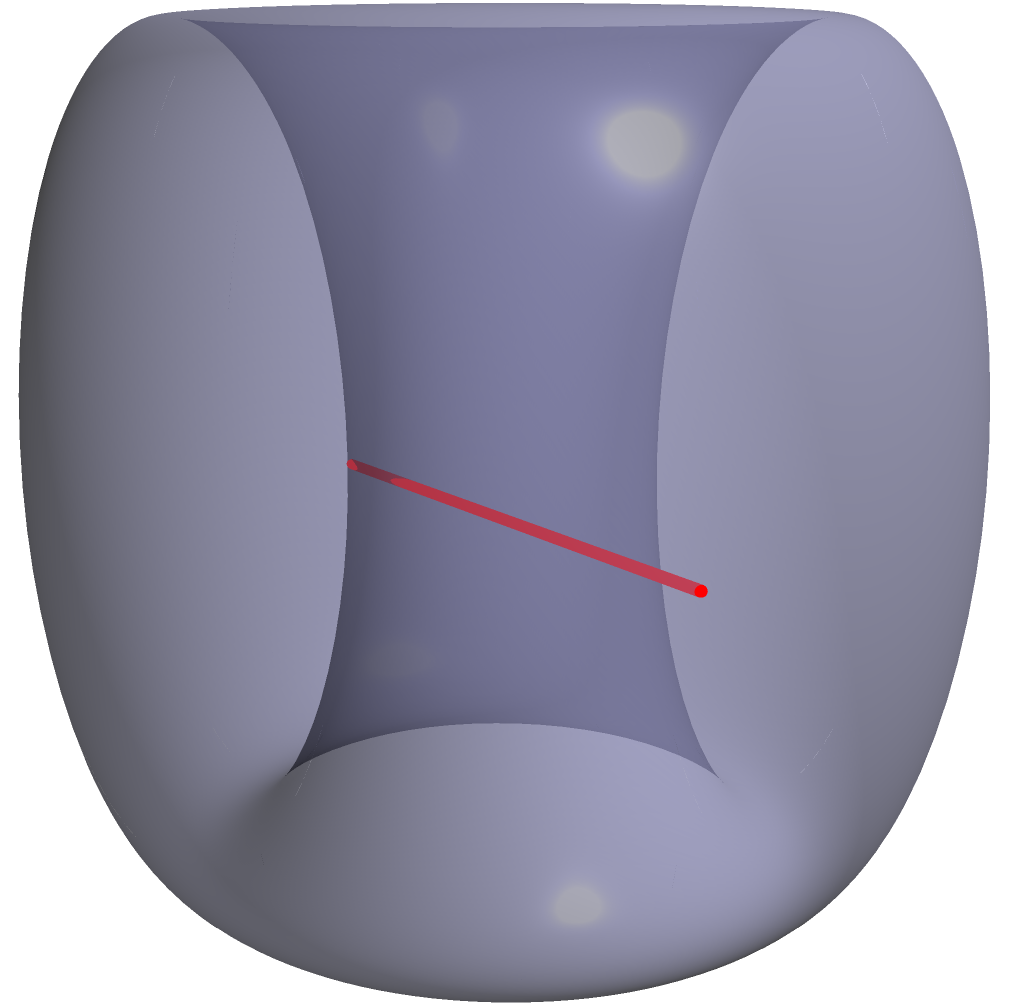In the latest episode of "Extraordinary Attorney Woo," the main character encounters a problem involving Non-Euclidean Geometry. She needs to find the shortest path between two points on a donut-shaped (torus) surface. If point A is located at $(π/4, 0)$ and point B is at $(7π/4, π)$ in torus coordinates, which path would be shorter: the straight line connecting A and B (red line) or the curved path along the surface (blue line)? Let's approach this step-by-step:

1) In Euclidean geometry, the shortest path between two points is always a straight line. However, on a curved surface like a torus, this is not always true.

2) The torus can be thought of as a rectangle with opposite edges identified. In this representation:
   - The horizontal direction represents the angle around the central axis (θ).
   - The vertical direction represents the angle around the tube (φ).

3) Given coordinates:
   - Point A: $(π/4, 0)$
   - Point B: $(7π/4, π)$

4) The straight line (red) passes through the torus, which is not a valid path on the surface.

5) The curved path (blue) follows the surface of the torus. It goes:
   - From A to the outer edge of the torus
   - Around the outer circumference to a point above B
   - Down to B

6) In the flattened torus representation, this path would look like a diagonal line from $(π/4, 0)$ to $(7π/4, π)$.

7) The shortest path on a curved surface is called a geodesic. On a torus, geodesics can have complex shapes, but they often follow paths similar to the blue line in our diagram.

8) Therefore, despite appearing longer in the 3D representation, the blue curved path is actually the shorter path between A and B on the surface of the torus.
Answer: The curved path (blue line) is shorter. 